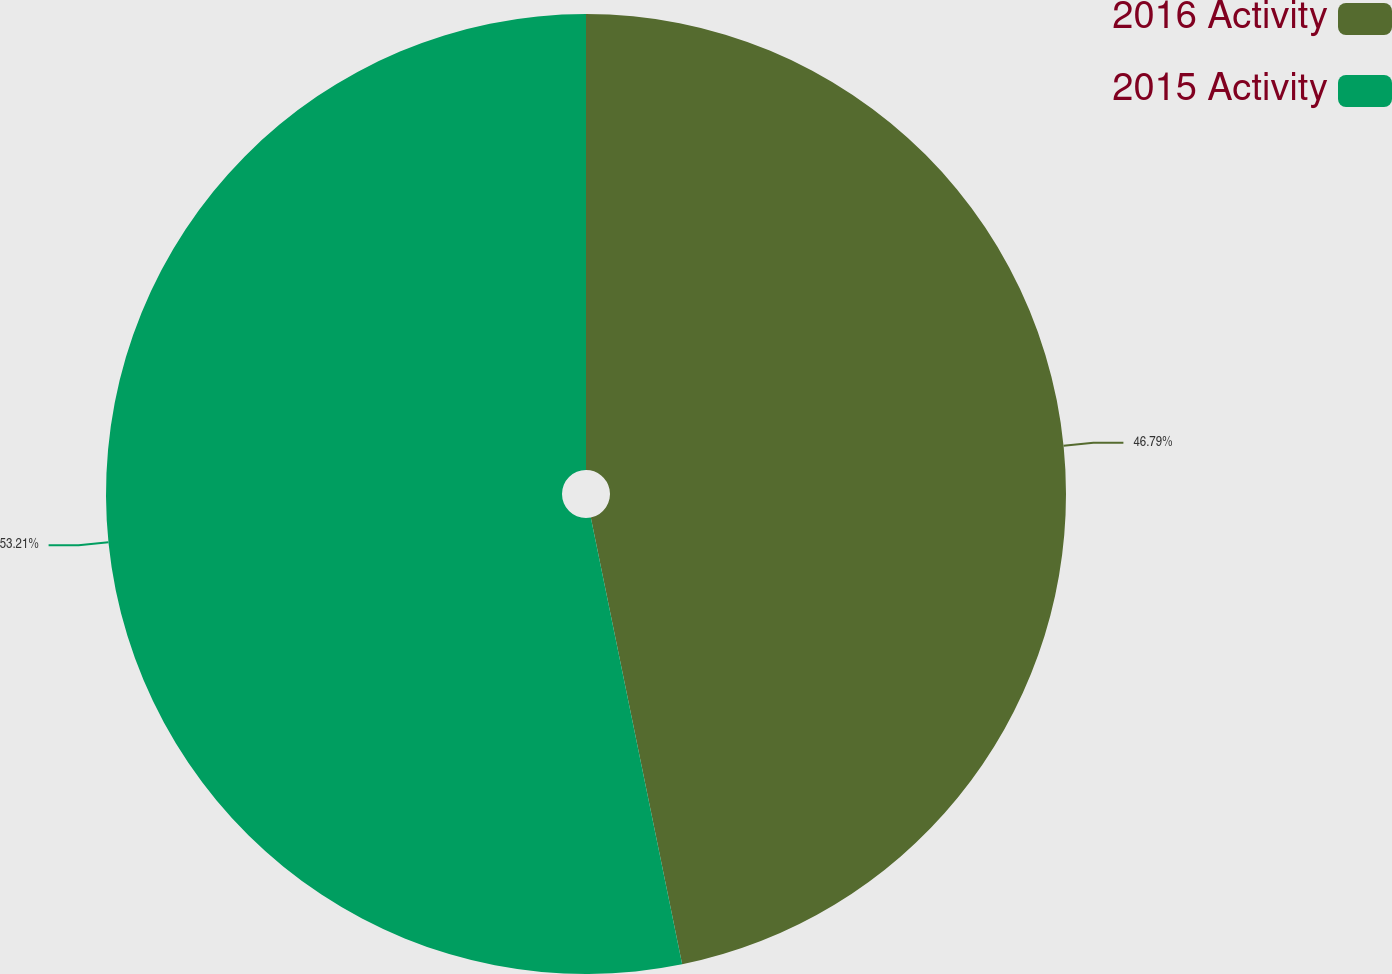<chart> <loc_0><loc_0><loc_500><loc_500><pie_chart><fcel>2016 Activity<fcel>2015 Activity<nl><fcel>46.79%<fcel>53.21%<nl></chart> 